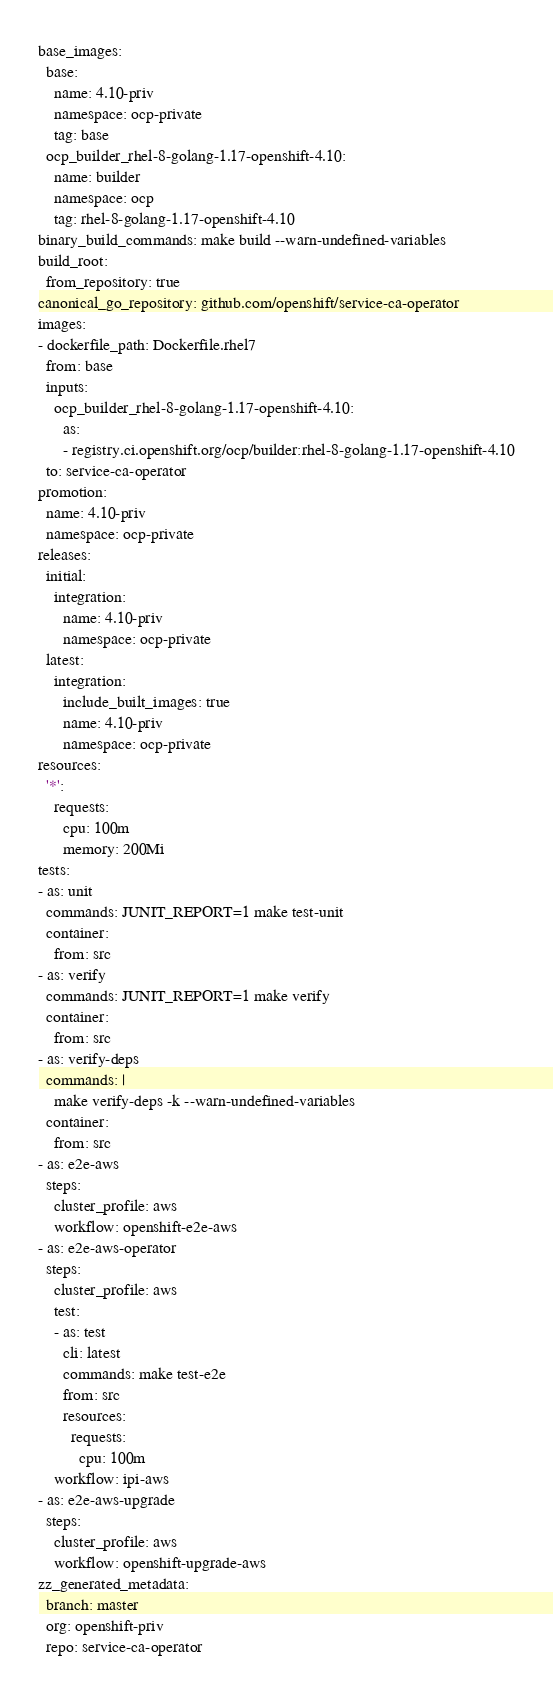Convert code to text. <code><loc_0><loc_0><loc_500><loc_500><_YAML_>base_images:
  base:
    name: 4.10-priv
    namespace: ocp-private
    tag: base
  ocp_builder_rhel-8-golang-1.17-openshift-4.10:
    name: builder
    namespace: ocp
    tag: rhel-8-golang-1.17-openshift-4.10
binary_build_commands: make build --warn-undefined-variables
build_root:
  from_repository: true
canonical_go_repository: github.com/openshift/service-ca-operator
images:
- dockerfile_path: Dockerfile.rhel7
  from: base
  inputs:
    ocp_builder_rhel-8-golang-1.17-openshift-4.10:
      as:
      - registry.ci.openshift.org/ocp/builder:rhel-8-golang-1.17-openshift-4.10
  to: service-ca-operator
promotion:
  name: 4.10-priv
  namespace: ocp-private
releases:
  initial:
    integration:
      name: 4.10-priv
      namespace: ocp-private
  latest:
    integration:
      include_built_images: true
      name: 4.10-priv
      namespace: ocp-private
resources:
  '*':
    requests:
      cpu: 100m
      memory: 200Mi
tests:
- as: unit
  commands: JUNIT_REPORT=1 make test-unit
  container:
    from: src
- as: verify
  commands: JUNIT_REPORT=1 make verify
  container:
    from: src
- as: verify-deps
  commands: |
    make verify-deps -k --warn-undefined-variables
  container:
    from: src
- as: e2e-aws
  steps:
    cluster_profile: aws
    workflow: openshift-e2e-aws
- as: e2e-aws-operator
  steps:
    cluster_profile: aws
    test:
    - as: test
      cli: latest
      commands: make test-e2e
      from: src
      resources:
        requests:
          cpu: 100m
    workflow: ipi-aws
- as: e2e-aws-upgrade
  steps:
    cluster_profile: aws
    workflow: openshift-upgrade-aws
zz_generated_metadata:
  branch: master
  org: openshift-priv
  repo: service-ca-operator
</code> 